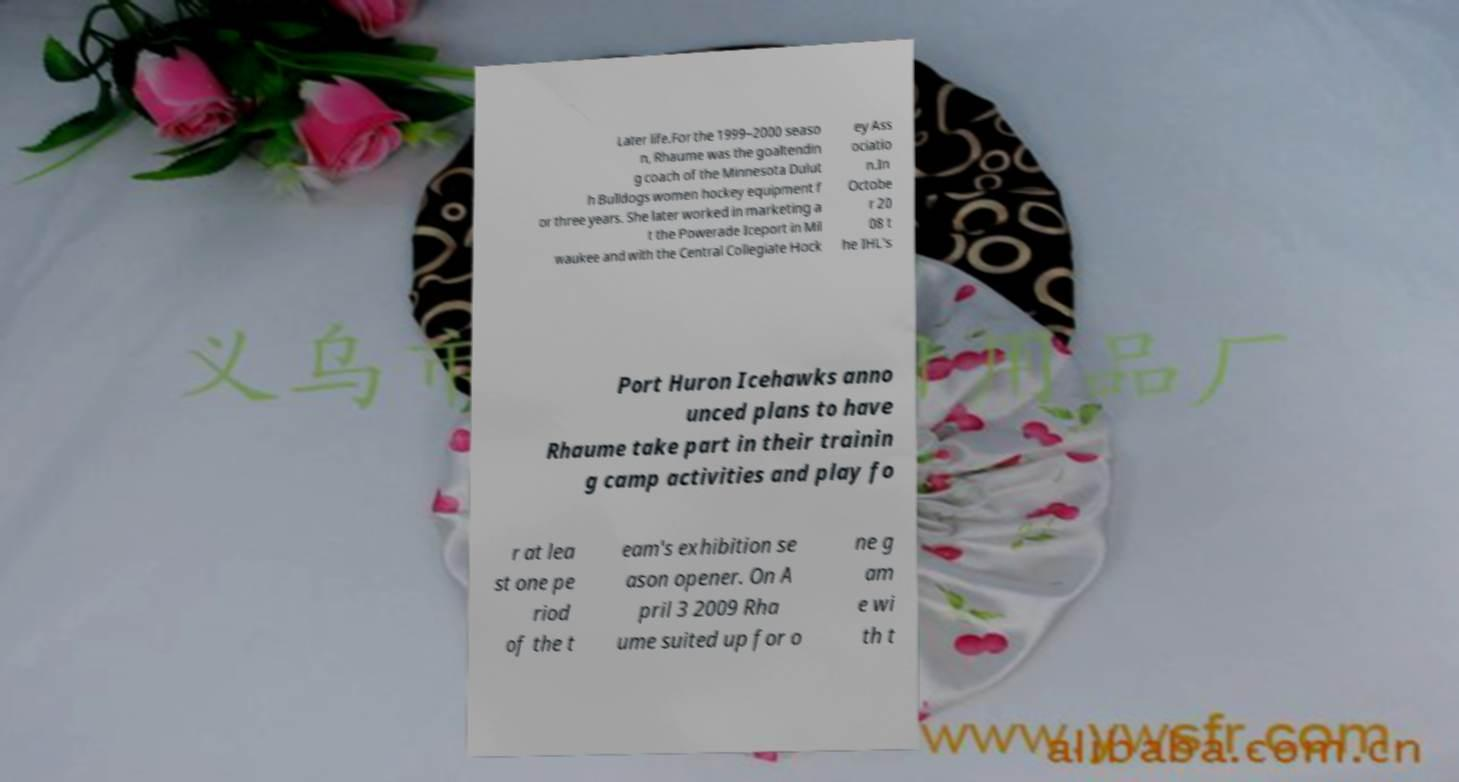There's text embedded in this image that I need extracted. Can you transcribe it verbatim? Later life.For the 1999–2000 seaso n, Rhaume was the goaltendin g coach of the Minnesota Dulut h Bulldogs women hockey equipment f or three years. She later worked in marketing a t the Powerade Iceport in Mil waukee and with the Central Collegiate Hock ey Ass ociatio n.In Octobe r 20 08 t he IHL's Port Huron Icehawks anno unced plans to have Rhaume take part in their trainin g camp activities and play fo r at lea st one pe riod of the t eam's exhibition se ason opener. On A pril 3 2009 Rha ume suited up for o ne g am e wi th t 